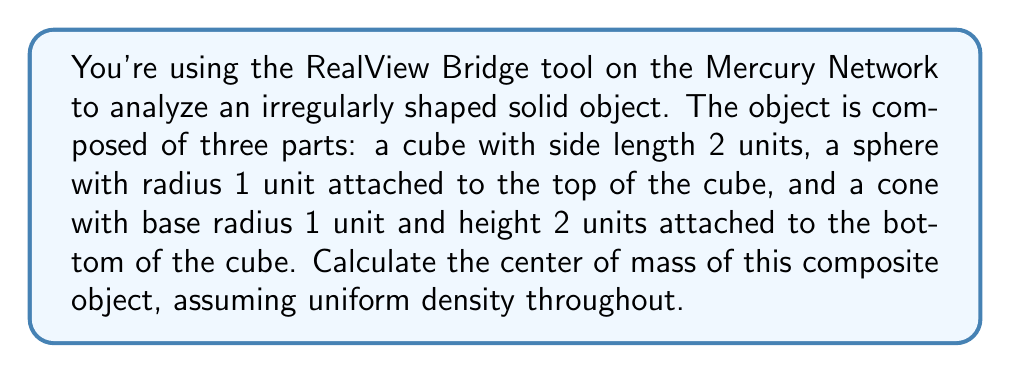Solve this math problem. Let's approach this step-by-step:

1) First, we need to calculate the volumes and centers of mass for each component:

   Cube: 
   Volume: $V_c = 2^3 = 8$ cubic units
   Center: $(1, 1, 1)$ (assuming the bottom left corner is at (0,0,0))

   Sphere:
   Volume: $V_s = \frac{4}{3}\pi r^3 = \frac{4}{3}\pi$ cubic units
   Center: $(1, 1, 3)$ (1 unit above the top of the cube)

   Cone:
   Volume: $V_n = \frac{1}{3}\pi r^2 h = \frac{1}{3}\pi$ cubic units
   Center: $(1, 1, -\frac{1}{2})$ (1/4 of the height up from the base)

2) The total volume is:

   $V_{total} = 8 + \frac{4}{3}\pi + \frac{1}{3}\pi = 8 + \frac{5}{3}\pi$

3) The center of mass formula for a composite object is:

   $\vec{r}_{CM} = \frac{\sum m_i \vec{r}_i}{\sum m_i} = \frac{\sum \rho V_i \vec{r}_i}{\sum \rho V_i} = \frac{\sum V_i \vec{r}_i}{\sum V_i}$

   Where $\vec{r}_i$ is the center of mass of each component and $V_i$ is its volume.

4) Applying this formula:

   $x_{CM} = y_{CM} = \frac{8(1) + \frac{4}{3}\pi(1) + \frac{1}{3}\pi(1)}{8 + \frac{5}{3}\pi} = 1$

   $z_{CM} = \frac{8(1) + \frac{4}{3}\pi(3) + \frac{1}{3}\pi(-\frac{1}{2})}{8 + \frac{5}{3}\pi}$

5) Simplifying the z-coordinate:

   $z_{CM} = \frac{8 + 4\pi - \frac{1}{6}\pi}{8 + \frac{5}{3}\pi} = \frac{24 + \frac{23}{2}\pi}{24 + 5\pi}$

Therefore, the center of mass is at $(1, 1, \frac{24 + \frac{23}{2}\pi}{24 + 5\pi})$.
Answer: $(1, 1, \frac{24 + \frac{23}{2}\pi}{24 + 5\pi})$ 